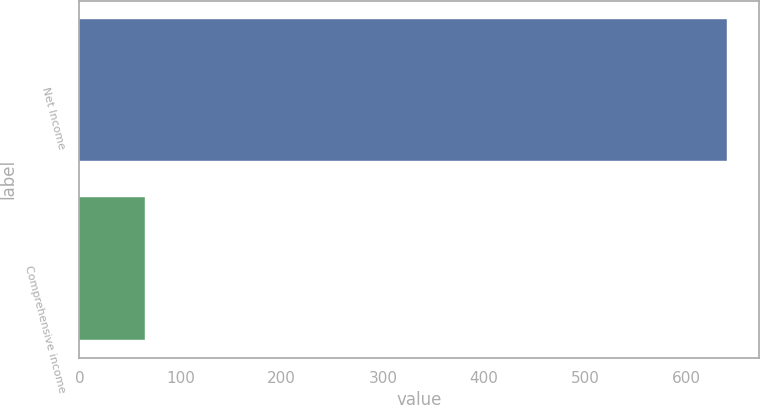<chart> <loc_0><loc_0><loc_500><loc_500><bar_chart><fcel>Net Income<fcel>Comprehensive income<nl><fcel>640<fcel>65<nl></chart> 